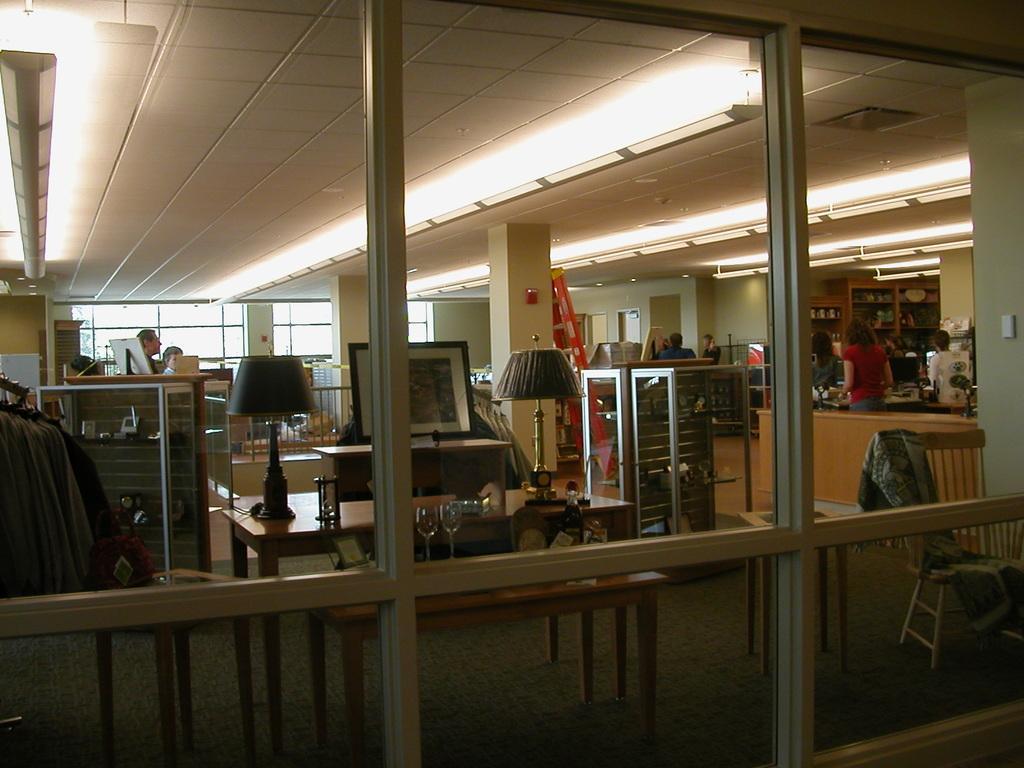In one or two sentences, can you explain what this image depicts? In the picture we can the see glass doors through which we can see the table lamps, glasses, monitors, tables, a few people standing on the right and left side of the image, we can see boards, cupboards, pillars and the ceiling lights in the background. 